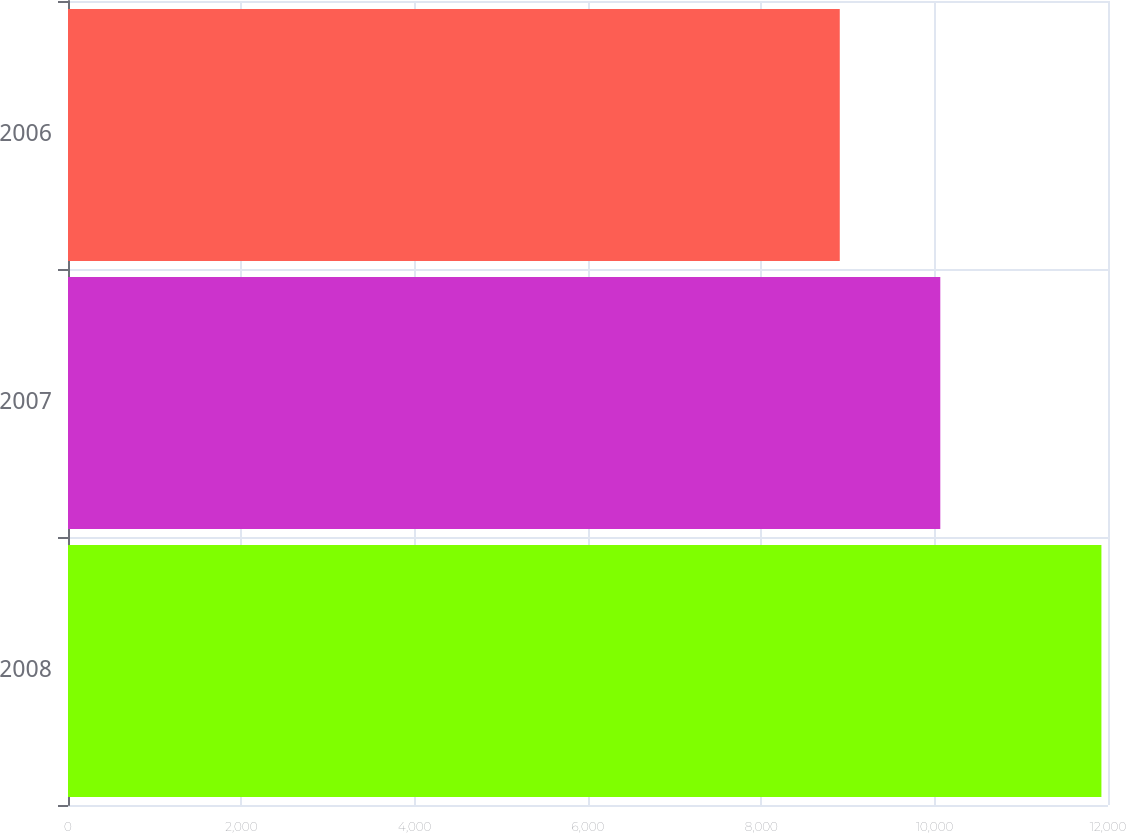Convert chart to OTSL. <chart><loc_0><loc_0><loc_500><loc_500><bar_chart><fcel>2008<fcel>2007<fcel>2006<nl><fcel>11924<fcel>10065<fcel>8905<nl></chart> 